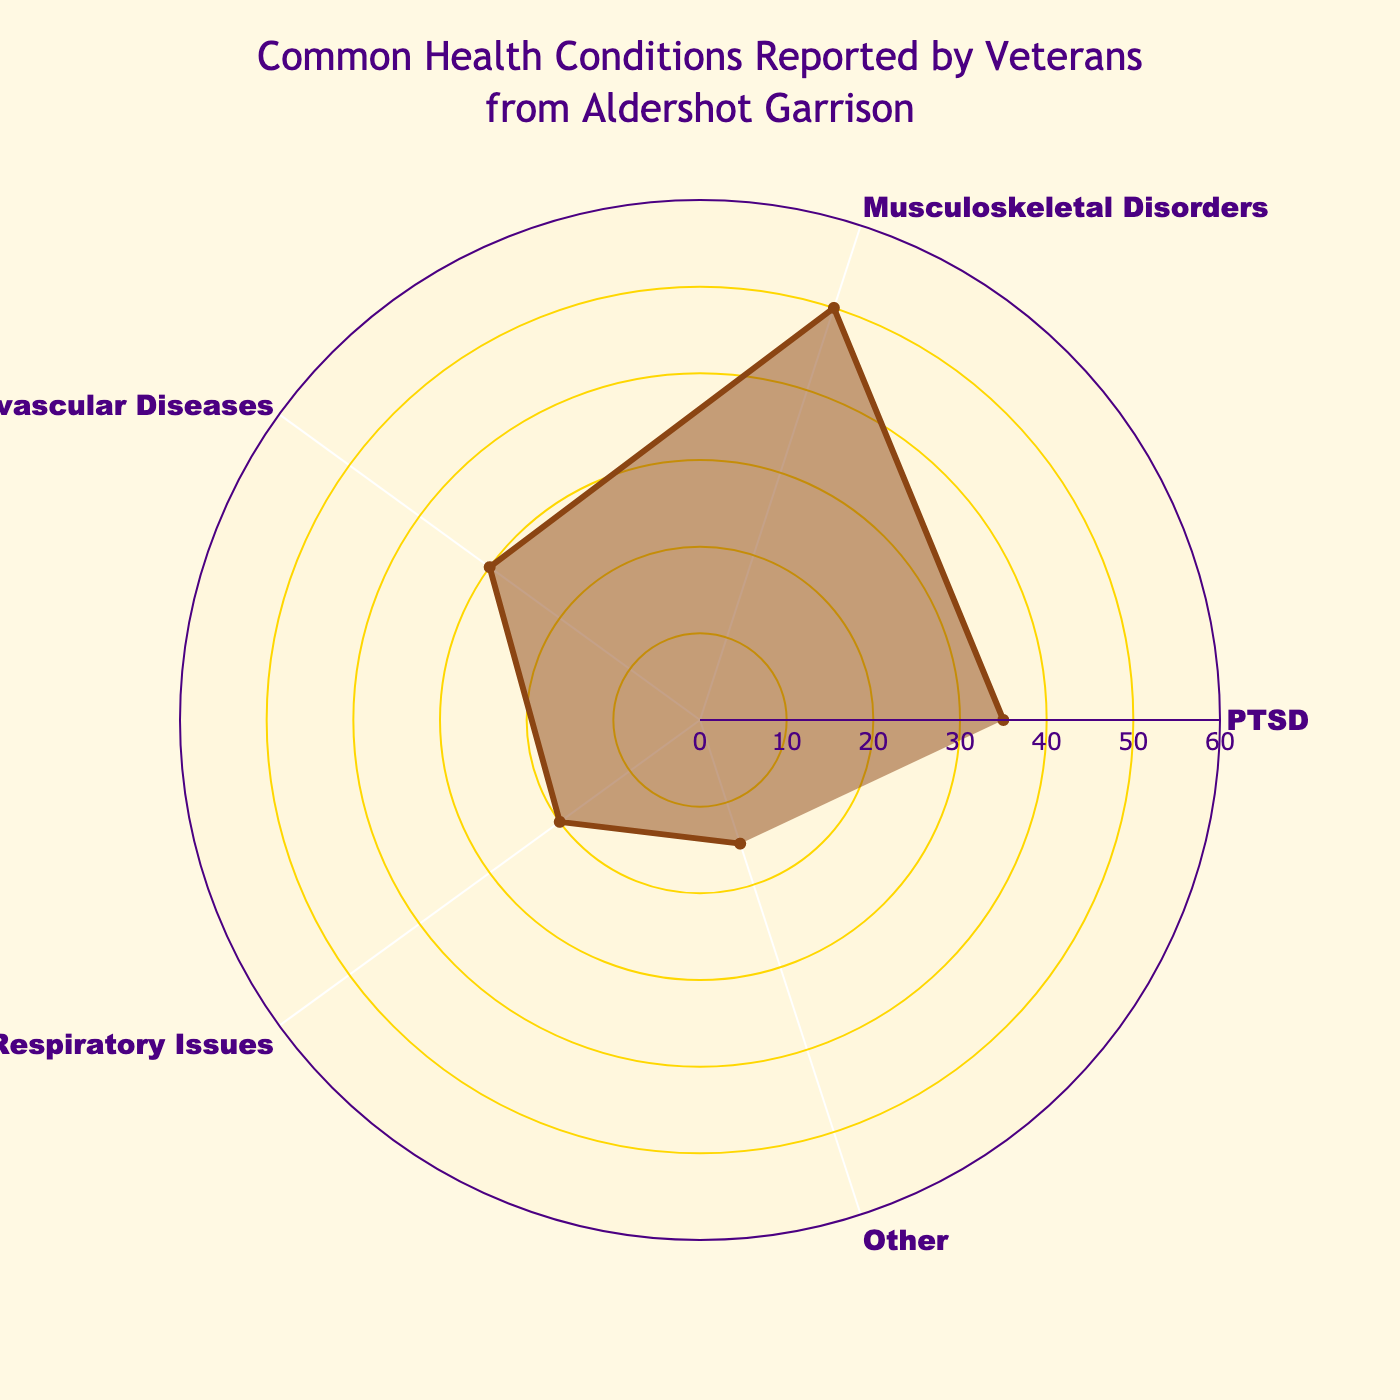What is the title of the chart? The title is at the top center of the chart and reads "Common Health Conditions Reported by Veterans from Aldershot Garrison".
Answer: Common Health Conditions Reported by Veterans from Aldershot Garrison What health condition has the highest reported value? By looking at the length of the radial lines in the polar chart, Musculoskeletal Disorders has the longest line, indicating it has the highest value of 50.
Answer: Musculoskeletal Disorders What is the range of the radial axis? The radial axis range is visible and goes from 0 to 60, with 60 being 1.2 times the highest value of 50.
Answer: 0-60 By how much does the value of Musculoskeletal Disorders exceed the value of Respiratory Issues? The value for Musculoskeletal Disorders is 50 and for Respiratory Issues is 20. The difference is 50 - 20 = 30.
Answer: 30 What is the combined value of PTSD, Cardiovascular Diseases, and Other? Adding the values: PTSD (35) + Cardiovascular Diseases (30) + Other (15) gives a total of 35 + 30 + 15 = 80.
Answer: 80 Which health condition is reported more frequently: PTSD or Cardiovascular Diseases? Comparing the radial line lengths, PTSD has a value of 35 and Cardiovascular Diseases has 30, so PTSD is reported more frequently.
Answer: PTSD What is the average value of all reported health conditions? There are 5 conditions with values: 35, 50, 30, 20, and 15. The sum is 150, and the average is 150 / 5 = 30.
Answer: 30 What color are the radial gridlines? The color of the radial gridlines is gold, which matches the description '#FFD700'.
Answer: Gold What is the smallest reported health condition? The radial line for 'Other' is the shortest, indicating a value of 15, which is the smallest among the health conditions.
Answer: Other 